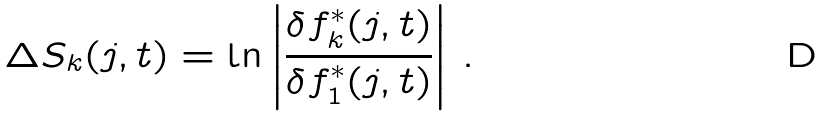<formula> <loc_0><loc_0><loc_500><loc_500>\Delta S _ { k } ( j , t ) = \ln \left | \frac { \delta f _ { k } ^ { * } ( j , t ) } { \delta f _ { 1 } ^ { * } ( j , t ) } \right | \, .</formula> 